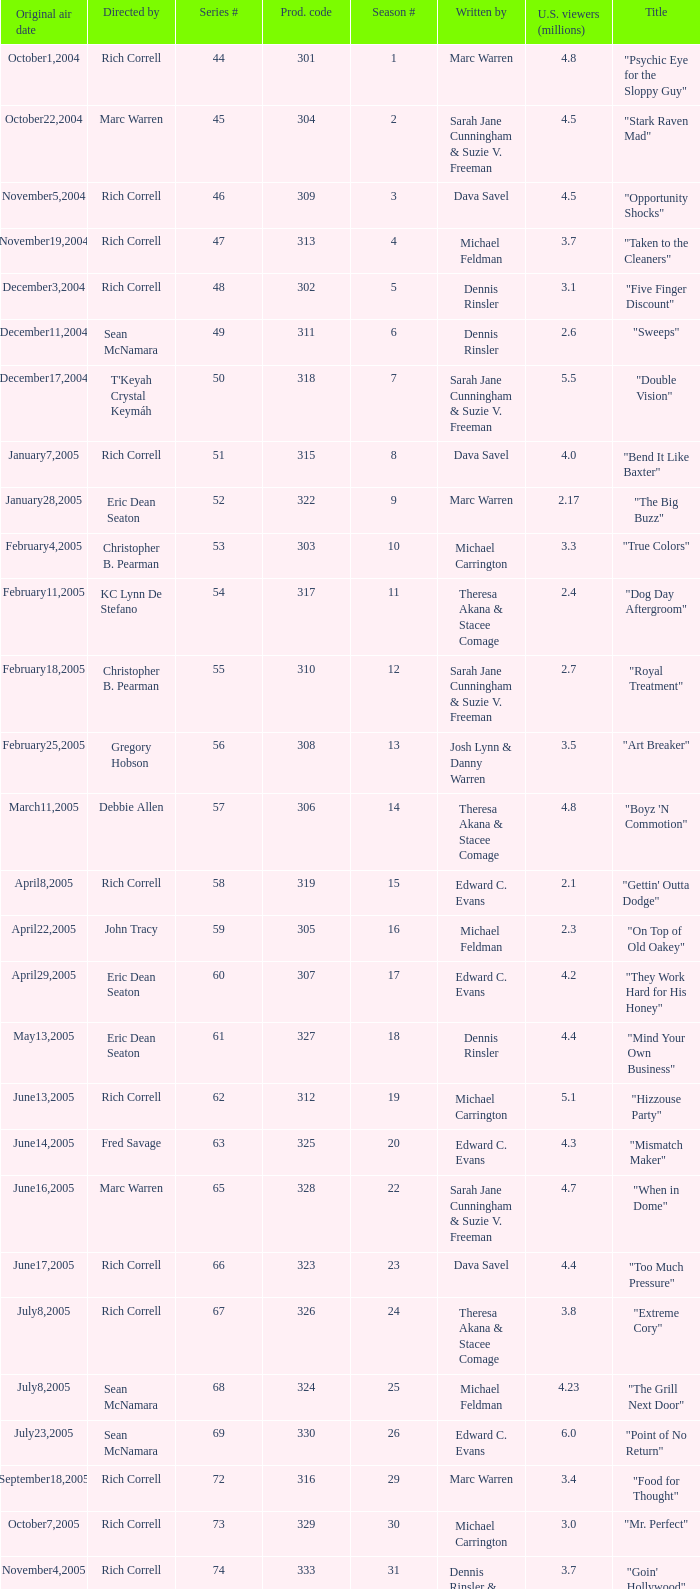What is the title of the episode directed by Rich Correll and written by Dennis Rinsler? "Five Finger Discount". Could you parse the entire table as a dict? {'header': ['Original air date', 'Directed by', 'Series #', 'Prod. code', 'Season #', 'Written by', 'U.S. viewers (millions)', 'Title'], 'rows': [['October1,2004', 'Rich Correll', '44', '301', '1', 'Marc Warren', '4.8', '"Psychic Eye for the Sloppy Guy"'], ['October22,2004', 'Marc Warren', '45', '304', '2', 'Sarah Jane Cunningham & Suzie V. Freeman', '4.5', '"Stark Raven Mad"'], ['November5,2004', 'Rich Correll', '46', '309', '3', 'Dava Savel', '4.5', '"Opportunity Shocks"'], ['November19,2004', 'Rich Correll', '47', '313', '4', 'Michael Feldman', '3.7', '"Taken to the Cleaners"'], ['December3,2004', 'Rich Correll', '48', '302', '5', 'Dennis Rinsler', '3.1', '"Five Finger Discount"'], ['December11,2004', 'Sean McNamara', '49', '311', '6', 'Dennis Rinsler', '2.6', '"Sweeps"'], ['December17,2004', "T'Keyah Crystal Keymáh", '50', '318', '7', 'Sarah Jane Cunningham & Suzie V. Freeman', '5.5', '"Double Vision"'], ['January7,2005', 'Rich Correll', '51', '315', '8', 'Dava Savel', '4.0', '"Bend It Like Baxter"'], ['January28,2005', 'Eric Dean Seaton', '52', '322', '9', 'Marc Warren', '2.17', '"The Big Buzz"'], ['February4,2005', 'Christopher B. Pearman', '53', '303', '10', 'Michael Carrington', '3.3', '"True Colors"'], ['February11,2005', 'KC Lynn De Stefano', '54', '317', '11', 'Theresa Akana & Stacee Comage', '2.4', '"Dog Day Aftergroom"'], ['February18,2005', 'Christopher B. Pearman', '55', '310', '12', 'Sarah Jane Cunningham & Suzie V. Freeman', '2.7', '"Royal Treatment"'], ['February25,2005', 'Gregory Hobson', '56', '308', '13', 'Josh Lynn & Danny Warren', '3.5', '"Art Breaker"'], ['March11,2005', 'Debbie Allen', '57', '306', '14', 'Theresa Akana & Stacee Comage', '4.8', '"Boyz \'N Commotion"'], ['April8,2005', 'Rich Correll', '58', '319', '15', 'Edward C. Evans', '2.1', '"Gettin\' Outta Dodge"'], ['April22,2005', 'John Tracy', '59', '305', '16', 'Michael Feldman', '2.3', '"On Top of Old Oakey"'], ['April29,2005', 'Eric Dean Seaton', '60', '307', '17', 'Edward C. Evans', '4.2', '"They Work Hard for His Honey"'], ['May13,2005', 'Eric Dean Seaton', '61', '327', '18', 'Dennis Rinsler', '4.4', '"Mind Your Own Business"'], ['June13,2005', 'Rich Correll', '62', '312', '19', 'Michael Carrington', '5.1', '"Hizzouse Party"'], ['June14,2005', 'Fred Savage', '63', '325', '20', 'Edward C. Evans', '4.3', '"Mismatch Maker"'], ['June16,2005', 'Marc Warren', '65', '328', '22', 'Sarah Jane Cunningham & Suzie V. Freeman', '4.7', '"When in Dome"'], ['June17,2005', 'Rich Correll', '66', '323', '23', 'Dava Savel', '4.4', '"Too Much Pressure"'], ['July8,2005', 'Rich Correll', '67', '326', '24', 'Theresa Akana & Stacee Comage', '3.8', '"Extreme Cory"'], ['July8,2005', 'Sean McNamara', '68', '324', '25', 'Michael Feldman', '4.23', '"The Grill Next Door"'], ['July23,2005', 'Sean McNamara', '69', '330', '26', 'Edward C. Evans', '6.0', '"Point of No Return"'], ['September18,2005', 'Rich Correll', '72', '316', '29', 'Marc Warren', '3.4', '"Food for Thought"'], ['October7,2005', 'Rich Correll', '73', '329', '30', 'Michael Carrington', '3.0', '"Mr. Perfect"'], ['November4,2005', 'Rich Correll', '74', '333', '31', 'Dennis Rinsler & Marc Warren', '3.7', '"Goin\' Hollywood"'], ['November25,2005', 'Sean McNamara', '75', '334', '32', 'Marc Warren', '3.3', '"Save the Last Dance"'], ['December16,2005', 'Rondell Sheridan', '76', '332', '33', 'Theresa Akana & Stacee Comage', '3.6', '"Cake Fear"'], ['January6,2006', 'Marc Warren', '77', '335', '34', 'David Brookwell & Sean McNamara', '4.7', '"Vision Impossible"']]} 